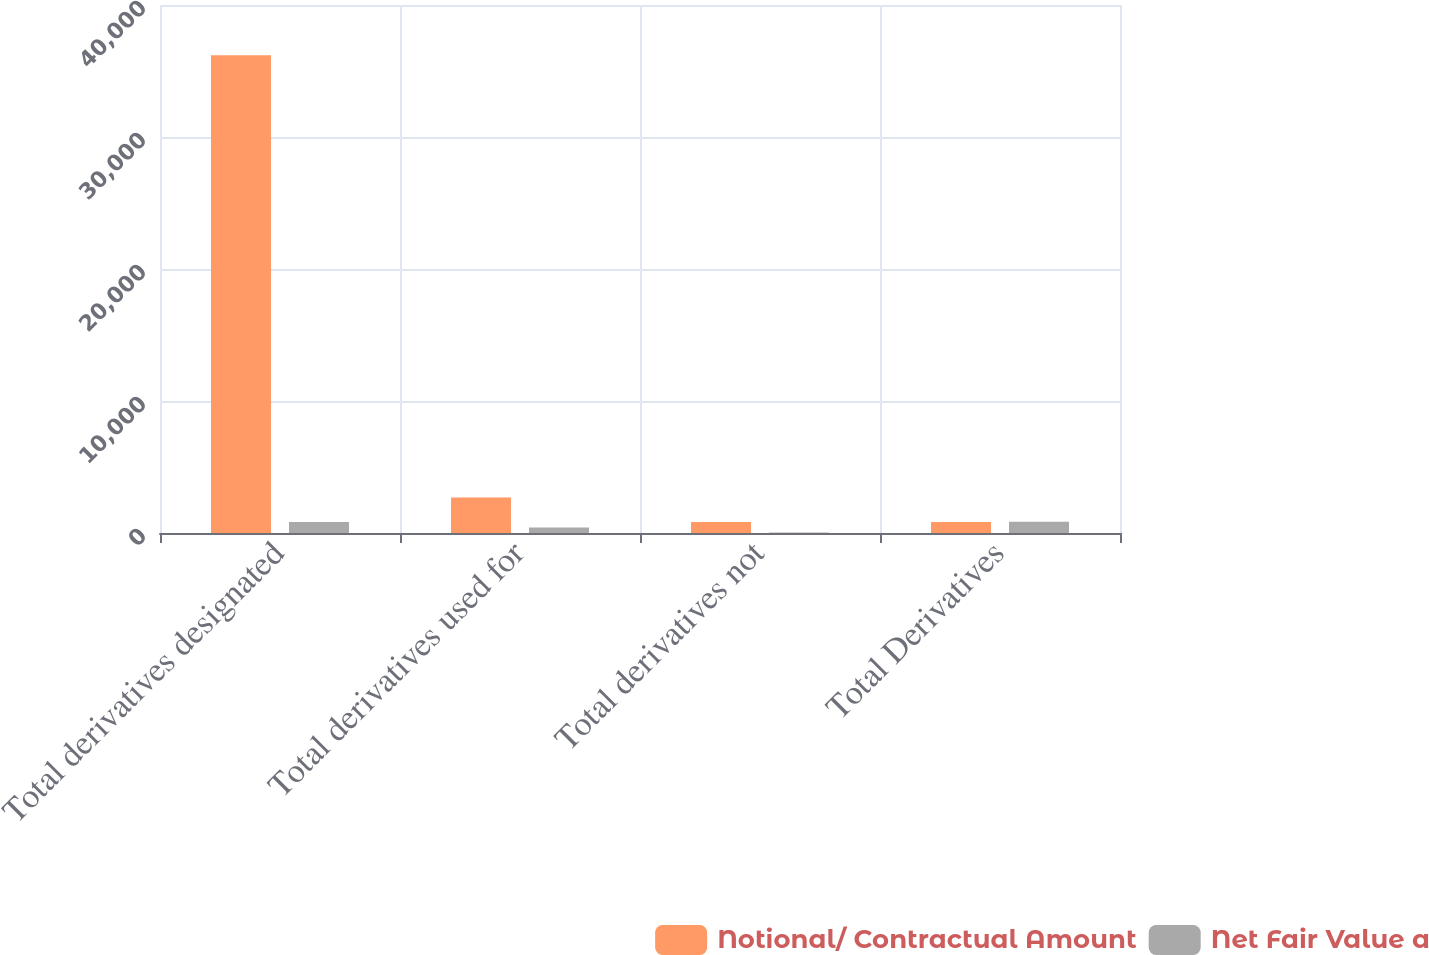Convert chart. <chart><loc_0><loc_0><loc_500><loc_500><stacked_bar_chart><ecel><fcel>Total derivatives designated<fcel>Total derivatives used for<fcel>Total derivatives not<fcel>Total Derivatives<nl><fcel>Notional/ Contractual Amount<fcel>36197<fcel>2697<fcel>842<fcel>842<nl><fcel>Net Fair Value a<fcel>825<fcel>422<fcel>34<fcel>859<nl></chart> 